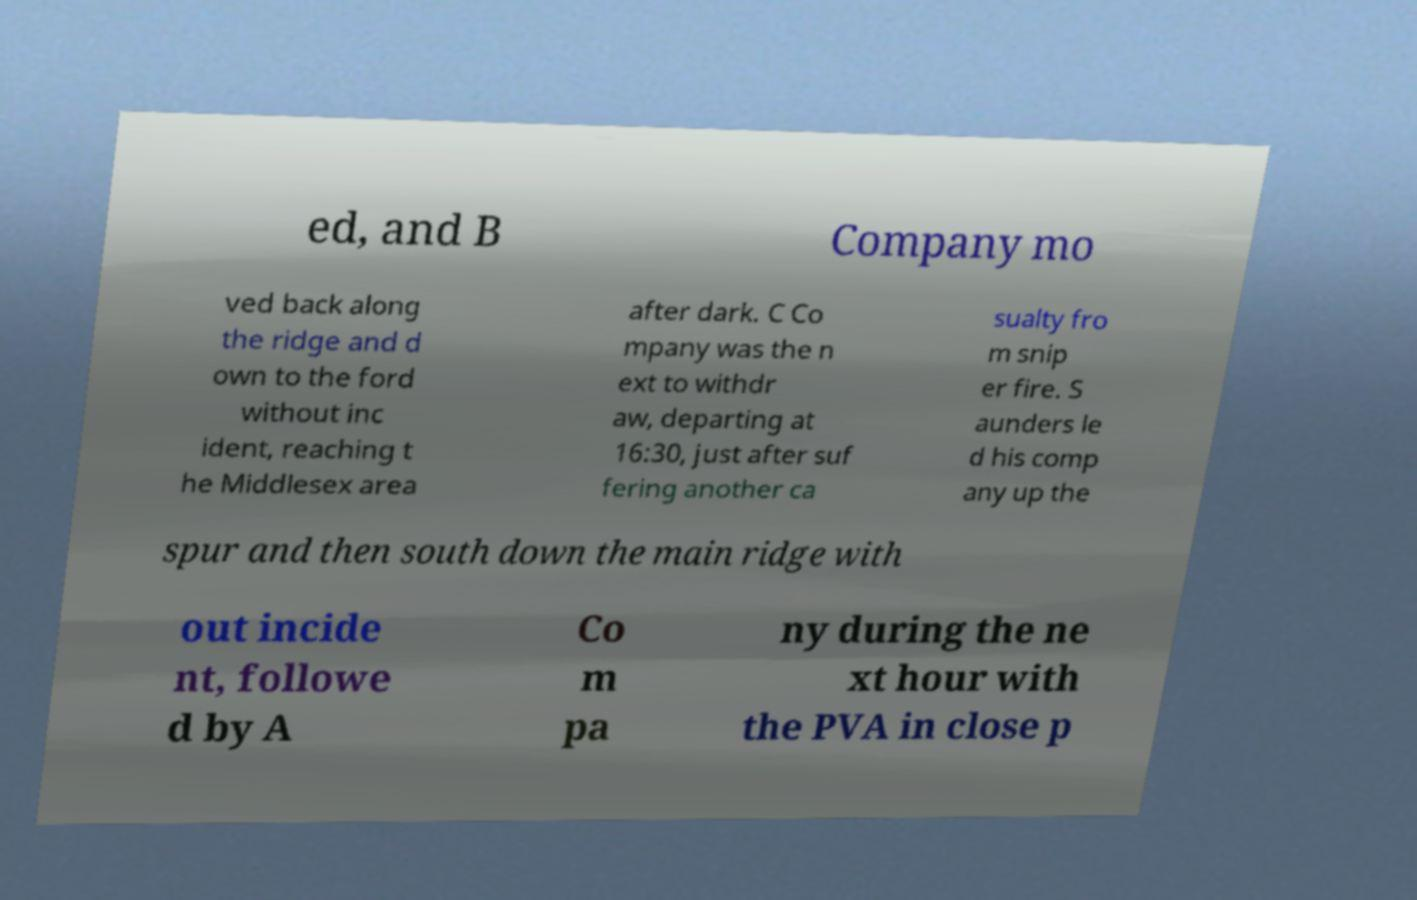Please identify and transcribe the text found in this image. ed, and B Company mo ved back along the ridge and d own to the ford without inc ident, reaching t he Middlesex area after dark. C Co mpany was the n ext to withdr aw, departing at 16:30, just after suf fering another ca sualty fro m snip er fire. S aunders le d his comp any up the spur and then south down the main ridge with out incide nt, followe d by A Co m pa ny during the ne xt hour with the PVA in close p 